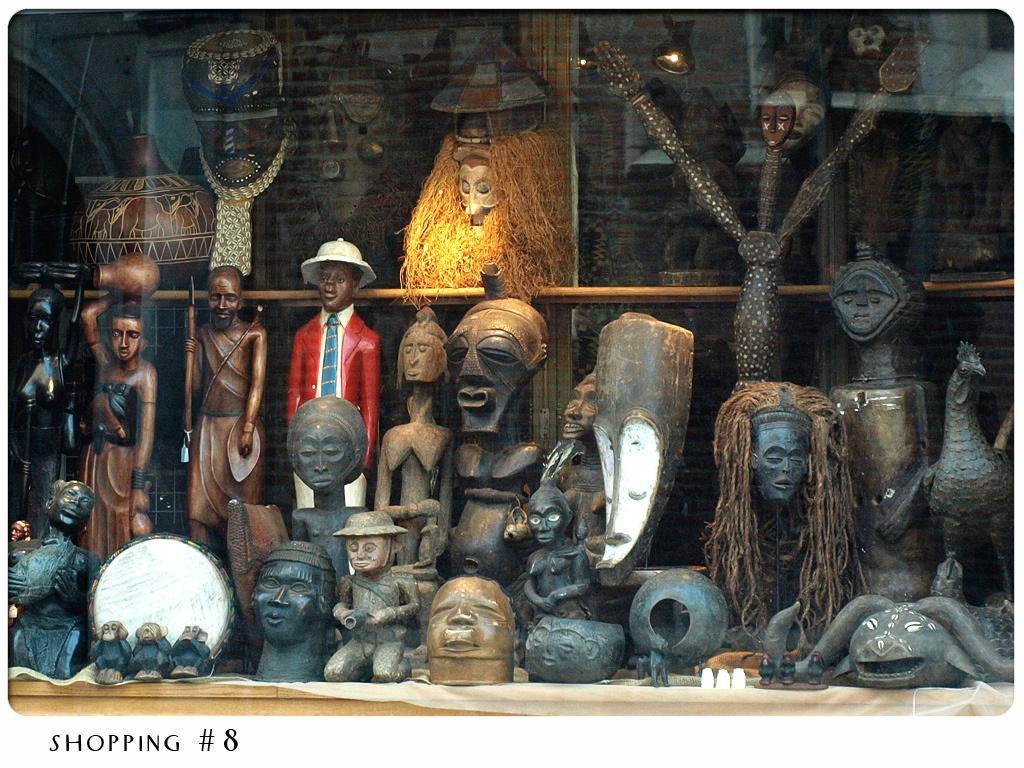Could you give a brief overview of what you see in this image? In this image I can see a cream colored desk and on the desk I can see few statues which are brown, red, white, green and black in color. I can see few ancient objects like statues of persons, animals and a pot. In the background I can see the wall which is made of bricks and few other objects. 